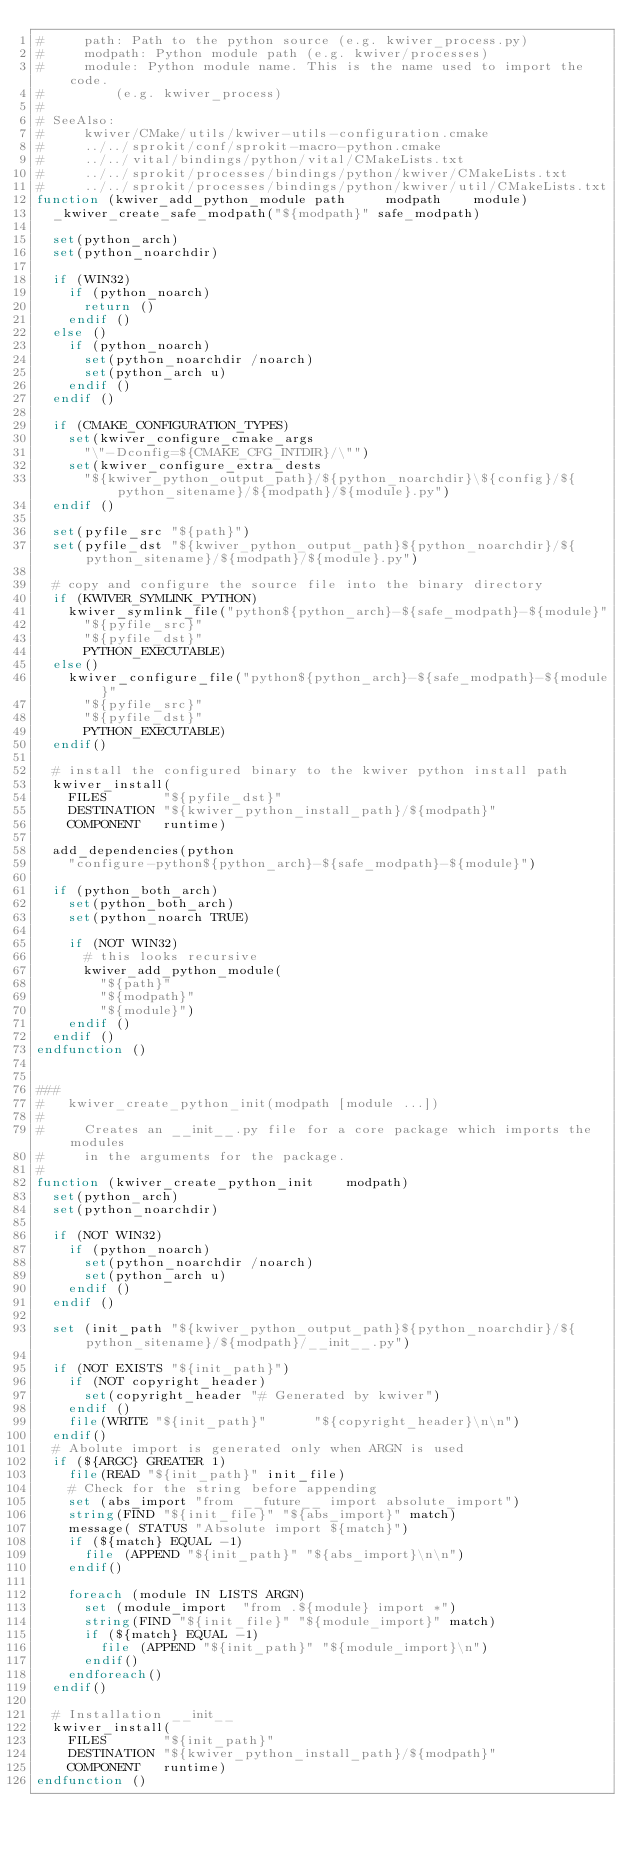Convert code to text. <code><loc_0><loc_0><loc_500><loc_500><_CMake_>#     path: Path to the python source (e.g. kwiver_process.py)
#     modpath: Python module path (e.g. kwiver/processes)
#     module: Python module name. This is the name used to import the code.
#         (e.g. kwiver_process)
#
# SeeAlso:
#     kwiver/CMake/utils/kwiver-utils-configuration.cmake
#     ../../sprokit/conf/sprokit-macro-python.cmake
#     ../../vital/bindings/python/vital/CMakeLists.txt
#     ../../sprokit/processes/bindings/python/kwiver/CMakeLists.txt
#     ../../sprokit/processes/bindings/python/kwiver/util/CMakeLists.txt
function (kwiver_add_python_module path     modpath    module)
  _kwiver_create_safe_modpath("${modpath}" safe_modpath)

  set(python_arch)
  set(python_noarchdir)

  if (WIN32)
    if (python_noarch)
      return ()
    endif ()
  else ()
    if (python_noarch)
      set(python_noarchdir /noarch)
      set(python_arch u)
    endif ()
  endif ()

  if (CMAKE_CONFIGURATION_TYPES)
    set(kwiver_configure_cmake_args
      "\"-Dconfig=${CMAKE_CFG_INTDIR}/\"")
    set(kwiver_configure_extra_dests
      "${kwiver_python_output_path}/${python_noarchdir}\${config}/${python_sitename}/${modpath}/${module}.py")
  endif ()

  set(pyfile_src "${path}")
  set(pyfile_dst "${kwiver_python_output_path}${python_noarchdir}/${python_sitename}/${modpath}/${module}.py")

  # copy and configure the source file into the binary directory
  if (KWIVER_SYMLINK_PYTHON)
    kwiver_symlink_file("python${python_arch}-${safe_modpath}-${module}"
      "${pyfile_src}"
      "${pyfile_dst}"
      PYTHON_EXECUTABLE)
  else()
    kwiver_configure_file("python${python_arch}-${safe_modpath}-${module}"
      "${pyfile_src}"
      "${pyfile_dst}"
      PYTHON_EXECUTABLE)
  endif()

  # install the configured binary to the kwiver python install path
  kwiver_install(
    FILES       "${pyfile_dst}"
    DESTINATION "${kwiver_python_install_path}/${modpath}"
    COMPONENT   runtime)

  add_dependencies(python
    "configure-python${python_arch}-${safe_modpath}-${module}")

  if (python_both_arch)
    set(python_both_arch)
    set(python_noarch TRUE)

    if (NOT WIN32)
      # this looks recursive
      kwiver_add_python_module(
        "${path}"
        "${modpath}"
        "${module}")
    endif ()
  endif ()
endfunction ()


###
#   kwiver_create_python_init(modpath [module ...])
#
#     Creates an __init__.py file for a core package which imports the modules
#     in the arguments for the package.
#
function (kwiver_create_python_init    modpath)
  set(python_arch)
  set(python_noarchdir)

  if (NOT WIN32)
    if (python_noarch)
      set(python_noarchdir /noarch)
      set(python_arch u)
    endif ()
  endif ()

  set (init_path "${kwiver_python_output_path}${python_noarchdir}/${python_sitename}/${modpath}/__init__.py")

  if (NOT EXISTS "${init_path}")
    if (NOT copyright_header)
      set(copyright_header "# Generated by kwiver")
    endif ()
    file(WRITE "${init_path}"      "${copyright_header}\n\n")
  endif()
  # Abolute import is generated only when ARGN is used
  if (${ARGC} GREATER 1)
    file(READ "${init_path}" init_file)
    # Check for the string before appending
    set (abs_import "from __future__ import absolute_import")
    string(FIND "${init_file}" "${abs_import}" match)
    message( STATUS "Absolute import ${match}")
    if (${match} EQUAL -1)
      file (APPEND "${init_path}" "${abs_import}\n\n")
    endif()

    foreach (module IN LISTS ARGN)
      set (module_import  "from .${module} import *")
      string(FIND "${init_file}" "${module_import}" match)
      if (${match} EQUAL -1)
        file (APPEND "${init_path}" "${module_import}\n")
      endif()
    endforeach()
  endif()

  # Installation __init__
  kwiver_install(
    FILES       "${init_path}"
    DESTINATION "${kwiver_python_install_path}/${modpath}"
    COMPONENT   runtime)
endfunction ()
</code> 